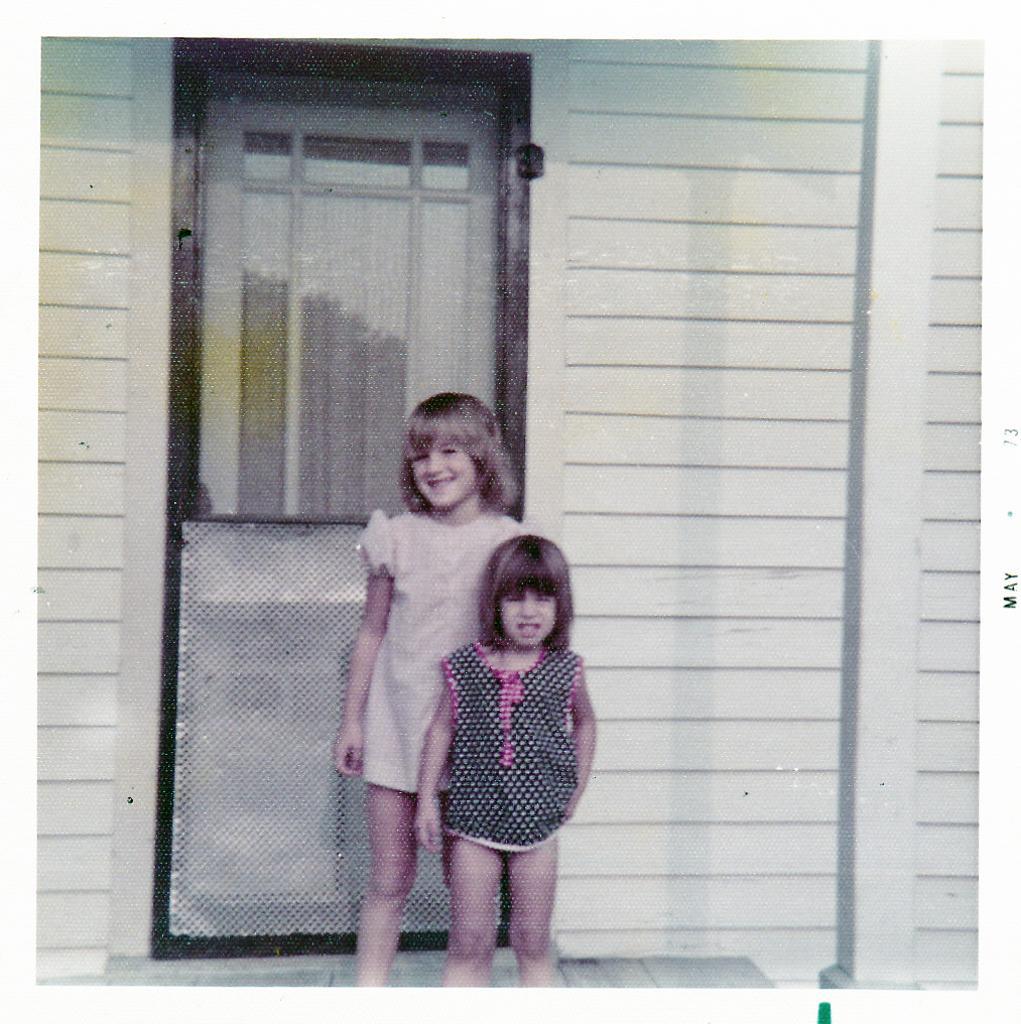Please provide a concise description of this image. In front of the image there are two kids standing. Behind them there is a closed door. There is a wall. On the right side of the image there is a pillar. 